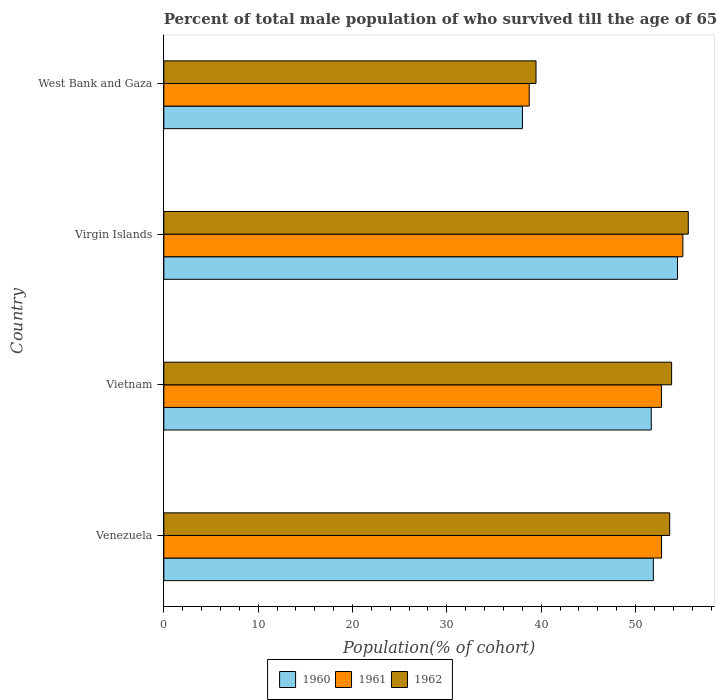How many different coloured bars are there?
Make the answer very short. 3. Are the number of bars per tick equal to the number of legend labels?
Your answer should be compact. Yes. Are the number of bars on each tick of the Y-axis equal?
Provide a short and direct response. Yes. How many bars are there on the 3rd tick from the bottom?
Offer a terse response. 3. What is the label of the 4th group of bars from the top?
Give a very brief answer. Venezuela. What is the percentage of total male population who survived till the age of 65 years in 1960 in Venezuela?
Offer a terse response. 51.89. Across all countries, what is the maximum percentage of total male population who survived till the age of 65 years in 1961?
Your answer should be compact. 55.02. Across all countries, what is the minimum percentage of total male population who survived till the age of 65 years in 1962?
Your answer should be compact. 39.45. In which country was the percentage of total male population who survived till the age of 65 years in 1962 maximum?
Your answer should be very brief. Virgin Islands. In which country was the percentage of total male population who survived till the age of 65 years in 1962 minimum?
Your answer should be very brief. West Bank and Gaza. What is the total percentage of total male population who survived till the age of 65 years in 1961 in the graph?
Your response must be concise. 199.26. What is the difference between the percentage of total male population who survived till the age of 65 years in 1960 in Vietnam and that in Virgin Islands?
Your answer should be compact. -2.78. What is the difference between the percentage of total male population who survived till the age of 65 years in 1961 in West Bank and Gaza and the percentage of total male population who survived till the age of 65 years in 1962 in Vietnam?
Provide a succinct answer. -15.09. What is the average percentage of total male population who survived till the age of 65 years in 1960 per country?
Provide a succinct answer. 49.01. What is the difference between the percentage of total male population who survived till the age of 65 years in 1960 and percentage of total male population who survived till the age of 65 years in 1962 in West Bank and Gaza?
Give a very brief answer. -1.44. In how many countries, is the percentage of total male population who survived till the age of 65 years in 1960 greater than 44 %?
Offer a terse response. 3. What is the ratio of the percentage of total male population who survived till the age of 65 years in 1962 in Vietnam to that in Virgin Islands?
Your response must be concise. 0.97. Is the percentage of total male population who survived till the age of 65 years in 1960 in Vietnam less than that in Virgin Islands?
Your answer should be very brief. Yes. Is the difference between the percentage of total male population who survived till the age of 65 years in 1960 in Vietnam and Virgin Islands greater than the difference between the percentage of total male population who survived till the age of 65 years in 1962 in Vietnam and Virgin Islands?
Ensure brevity in your answer.  No. What is the difference between the highest and the second highest percentage of total male population who survived till the age of 65 years in 1962?
Your answer should be compact. 1.76. What is the difference between the highest and the lowest percentage of total male population who survived till the age of 65 years in 1961?
Make the answer very short. 16.29. Are all the bars in the graph horizontal?
Provide a succinct answer. Yes. Are the values on the major ticks of X-axis written in scientific E-notation?
Give a very brief answer. No. Does the graph contain any zero values?
Your answer should be compact. No. Where does the legend appear in the graph?
Keep it short and to the point. Bottom center. How many legend labels are there?
Your answer should be compact. 3. What is the title of the graph?
Make the answer very short. Percent of total male population of who survived till the age of 65 years. What is the label or title of the X-axis?
Offer a terse response. Population(% of cohort). What is the Population(% of cohort) in 1960 in Venezuela?
Your answer should be compact. 51.89. What is the Population(% of cohort) of 1961 in Venezuela?
Keep it short and to the point. 52.76. What is the Population(% of cohort) in 1962 in Venezuela?
Give a very brief answer. 53.62. What is the Population(% of cohort) of 1960 in Vietnam?
Provide a succinct answer. 51.67. What is the Population(% of cohort) in 1961 in Vietnam?
Your answer should be very brief. 52.75. What is the Population(% of cohort) of 1962 in Vietnam?
Offer a terse response. 53.83. What is the Population(% of cohort) of 1960 in Virgin Islands?
Your response must be concise. 54.45. What is the Population(% of cohort) of 1961 in Virgin Islands?
Offer a very short reply. 55.02. What is the Population(% of cohort) of 1962 in Virgin Islands?
Ensure brevity in your answer.  55.59. What is the Population(% of cohort) of 1960 in West Bank and Gaza?
Offer a very short reply. 38.02. What is the Population(% of cohort) in 1961 in West Bank and Gaza?
Provide a succinct answer. 38.73. What is the Population(% of cohort) of 1962 in West Bank and Gaza?
Offer a terse response. 39.45. Across all countries, what is the maximum Population(% of cohort) in 1960?
Your response must be concise. 54.45. Across all countries, what is the maximum Population(% of cohort) in 1961?
Keep it short and to the point. 55.02. Across all countries, what is the maximum Population(% of cohort) in 1962?
Offer a terse response. 55.59. Across all countries, what is the minimum Population(% of cohort) in 1960?
Ensure brevity in your answer.  38.02. Across all countries, what is the minimum Population(% of cohort) in 1961?
Your answer should be very brief. 38.73. Across all countries, what is the minimum Population(% of cohort) of 1962?
Your response must be concise. 39.45. What is the total Population(% of cohort) of 1960 in the graph?
Your answer should be very brief. 196.03. What is the total Population(% of cohort) in 1961 in the graph?
Offer a very short reply. 199.26. What is the total Population(% of cohort) of 1962 in the graph?
Make the answer very short. 202.49. What is the difference between the Population(% of cohort) of 1960 in Venezuela and that in Vietnam?
Provide a short and direct response. 0.22. What is the difference between the Population(% of cohort) of 1961 in Venezuela and that in Vietnam?
Provide a succinct answer. 0.01. What is the difference between the Population(% of cohort) of 1962 in Venezuela and that in Vietnam?
Give a very brief answer. -0.21. What is the difference between the Population(% of cohort) in 1960 in Venezuela and that in Virgin Islands?
Offer a very short reply. -2.56. What is the difference between the Population(% of cohort) in 1961 in Venezuela and that in Virgin Islands?
Give a very brief answer. -2.26. What is the difference between the Population(% of cohort) in 1962 in Venezuela and that in Virgin Islands?
Give a very brief answer. -1.97. What is the difference between the Population(% of cohort) of 1960 in Venezuela and that in West Bank and Gaza?
Your answer should be compact. 13.88. What is the difference between the Population(% of cohort) of 1961 in Venezuela and that in West Bank and Gaza?
Give a very brief answer. 14.02. What is the difference between the Population(% of cohort) of 1962 in Venezuela and that in West Bank and Gaza?
Offer a terse response. 14.17. What is the difference between the Population(% of cohort) in 1960 in Vietnam and that in Virgin Islands?
Provide a short and direct response. -2.78. What is the difference between the Population(% of cohort) in 1961 in Vietnam and that in Virgin Islands?
Keep it short and to the point. -2.27. What is the difference between the Population(% of cohort) of 1962 in Vietnam and that in Virgin Islands?
Offer a terse response. -1.76. What is the difference between the Population(% of cohort) of 1960 in Vietnam and that in West Bank and Gaza?
Your response must be concise. 13.65. What is the difference between the Population(% of cohort) of 1961 in Vietnam and that in West Bank and Gaza?
Your answer should be very brief. 14.01. What is the difference between the Population(% of cohort) of 1962 in Vietnam and that in West Bank and Gaza?
Keep it short and to the point. 14.38. What is the difference between the Population(% of cohort) in 1960 in Virgin Islands and that in West Bank and Gaza?
Provide a short and direct response. 16.44. What is the difference between the Population(% of cohort) in 1961 in Virgin Islands and that in West Bank and Gaza?
Make the answer very short. 16.29. What is the difference between the Population(% of cohort) in 1962 in Virgin Islands and that in West Bank and Gaza?
Make the answer very short. 16.14. What is the difference between the Population(% of cohort) of 1960 in Venezuela and the Population(% of cohort) of 1961 in Vietnam?
Your answer should be very brief. -0.86. What is the difference between the Population(% of cohort) in 1960 in Venezuela and the Population(% of cohort) in 1962 in Vietnam?
Offer a very short reply. -1.94. What is the difference between the Population(% of cohort) in 1961 in Venezuela and the Population(% of cohort) in 1962 in Vietnam?
Your response must be concise. -1.07. What is the difference between the Population(% of cohort) of 1960 in Venezuela and the Population(% of cohort) of 1961 in Virgin Islands?
Offer a very short reply. -3.13. What is the difference between the Population(% of cohort) in 1960 in Venezuela and the Population(% of cohort) in 1962 in Virgin Islands?
Keep it short and to the point. -3.7. What is the difference between the Population(% of cohort) in 1961 in Venezuela and the Population(% of cohort) in 1962 in Virgin Islands?
Your response must be concise. -2.83. What is the difference between the Population(% of cohort) of 1960 in Venezuela and the Population(% of cohort) of 1961 in West Bank and Gaza?
Your response must be concise. 13.16. What is the difference between the Population(% of cohort) in 1960 in Venezuela and the Population(% of cohort) in 1962 in West Bank and Gaza?
Provide a succinct answer. 12.44. What is the difference between the Population(% of cohort) in 1961 in Venezuela and the Population(% of cohort) in 1962 in West Bank and Gaza?
Offer a very short reply. 13.3. What is the difference between the Population(% of cohort) in 1960 in Vietnam and the Population(% of cohort) in 1961 in Virgin Islands?
Make the answer very short. -3.35. What is the difference between the Population(% of cohort) in 1960 in Vietnam and the Population(% of cohort) in 1962 in Virgin Islands?
Your response must be concise. -3.92. What is the difference between the Population(% of cohort) of 1961 in Vietnam and the Population(% of cohort) of 1962 in Virgin Islands?
Make the answer very short. -2.84. What is the difference between the Population(% of cohort) in 1960 in Vietnam and the Population(% of cohort) in 1961 in West Bank and Gaza?
Ensure brevity in your answer.  12.93. What is the difference between the Population(% of cohort) of 1960 in Vietnam and the Population(% of cohort) of 1962 in West Bank and Gaza?
Your response must be concise. 12.22. What is the difference between the Population(% of cohort) of 1961 in Vietnam and the Population(% of cohort) of 1962 in West Bank and Gaza?
Make the answer very short. 13.3. What is the difference between the Population(% of cohort) of 1960 in Virgin Islands and the Population(% of cohort) of 1961 in West Bank and Gaza?
Make the answer very short. 15.72. What is the difference between the Population(% of cohort) in 1960 in Virgin Islands and the Population(% of cohort) in 1962 in West Bank and Gaza?
Keep it short and to the point. 15. What is the difference between the Population(% of cohort) of 1961 in Virgin Islands and the Population(% of cohort) of 1962 in West Bank and Gaza?
Keep it short and to the point. 15.57. What is the average Population(% of cohort) of 1960 per country?
Your answer should be very brief. 49.01. What is the average Population(% of cohort) in 1961 per country?
Provide a succinct answer. 49.81. What is the average Population(% of cohort) in 1962 per country?
Your answer should be compact. 50.62. What is the difference between the Population(% of cohort) in 1960 and Population(% of cohort) in 1961 in Venezuela?
Provide a short and direct response. -0.87. What is the difference between the Population(% of cohort) in 1960 and Population(% of cohort) in 1962 in Venezuela?
Your answer should be very brief. -1.73. What is the difference between the Population(% of cohort) of 1961 and Population(% of cohort) of 1962 in Venezuela?
Provide a succinct answer. -0.87. What is the difference between the Population(% of cohort) of 1960 and Population(% of cohort) of 1961 in Vietnam?
Ensure brevity in your answer.  -1.08. What is the difference between the Population(% of cohort) of 1960 and Population(% of cohort) of 1962 in Vietnam?
Give a very brief answer. -2.16. What is the difference between the Population(% of cohort) of 1961 and Population(% of cohort) of 1962 in Vietnam?
Your response must be concise. -1.08. What is the difference between the Population(% of cohort) in 1960 and Population(% of cohort) in 1961 in Virgin Islands?
Your answer should be very brief. -0.57. What is the difference between the Population(% of cohort) of 1960 and Population(% of cohort) of 1962 in Virgin Islands?
Ensure brevity in your answer.  -1.14. What is the difference between the Population(% of cohort) in 1961 and Population(% of cohort) in 1962 in Virgin Islands?
Offer a very short reply. -0.57. What is the difference between the Population(% of cohort) in 1960 and Population(% of cohort) in 1961 in West Bank and Gaza?
Provide a short and direct response. -0.72. What is the difference between the Population(% of cohort) in 1960 and Population(% of cohort) in 1962 in West Bank and Gaza?
Ensure brevity in your answer.  -1.44. What is the difference between the Population(% of cohort) in 1961 and Population(% of cohort) in 1962 in West Bank and Gaza?
Your response must be concise. -0.72. What is the ratio of the Population(% of cohort) of 1960 in Venezuela to that in Vietnam?
Your answer should be very brief. 1. What is the ratio of the Population(% of cohort) of 1960 in Venezuela to that in Virgin Islands?
Make the answer very short. 0.95. What is the ratio of the Population(% of cohort) in 1961 in Venezuela to that in Virgin Islands?
Your response must be concise. 0.96. What is the ratio of the Population(% of cohort) in 1962 in Venezuela to that in Virgin Islands?
Make the answer very short. 0.96. What is the ratio of the Population(% of cohort) of 1960 in Venezuela to that in West Bank and Gaza?
Your response must be concise. 1.36. What is the ratio of the Population(% of cohort) in 1961 in Venezuela to that in West Bank and Gaza?
Offer a terse response. 1.36. What is the ratio of the Population(% of cohort) in 1962 in Venezuela to that in West Bank and Gaza?
Keep it short and to the point. 1.36. What is the ratio of the Population(% of cohort) of 1960 in Vietnam to that in Virgin Islands?
Ensure brevity in your answer.  0.95. What is the ratio of the Population(% of cohort) of 1961 in Vietnam to that in Virgin Islands?
Provide a short and direct response. 0.96. What is the ratio of the Population(% of cohort) in 1962 in Vietnam to that in Virgin Islands?
Your answer should be compact. 0.97. What is the ratio of the Population(% of cohort) of 1960 in Vietnam to that in West Bank and Gaza?
Ensure brevity in your answer.  1.36. What is the ratio of the Population(% of cohort) of 1961 in Vietnam to that in West Bank and Gaza?
Your answer should be very brief. 1.36. What is the ratio of the Population(% of cohort) in 1962 in Vietnam to that in West Bank and Gaza?
Your response must be concise. 1.36. What is the ratio of the Population(% of cohort) in 1960 in Virgin Islands to that in West Bank and Gaza?
Provide a short and direct response. 1.43. What is the ratio of the Population(% of cohort) of 1961 in Virgin Islands to that in West Bank and Gaza?
Ensure brevity in your answer.  1.42. What is the ratio of the Population(% of cohort) of 1962 in Virgin Islands to that in West Bank and Gaza?
Offer a very short reply. 1.41. What is the difference between the highest and the second highest Population(% of cohort) in 1960?
Ensure brevity in your answer.  2.56. What is the difference between the highest and the second highest Population(% of cohort) in 1961?
Ensure brevity in your answer.  2.26. What is the difference between the highest and the second highest Population(% of cohort) in 1962?
Provide a succinct answer. 1.76. What is the difference between the highest and the lowest Population(% of cohort) in 1960?
Ensure brevity in your answer.  16.44. What is the difference between the highest and the lowest Population(% of cohort) in 1961?
Make the answer very short. 16.29. What is the difference between the highest and the lowest Population(% of cohort) of 1962?
Provide a short and direct response. 16.14. 